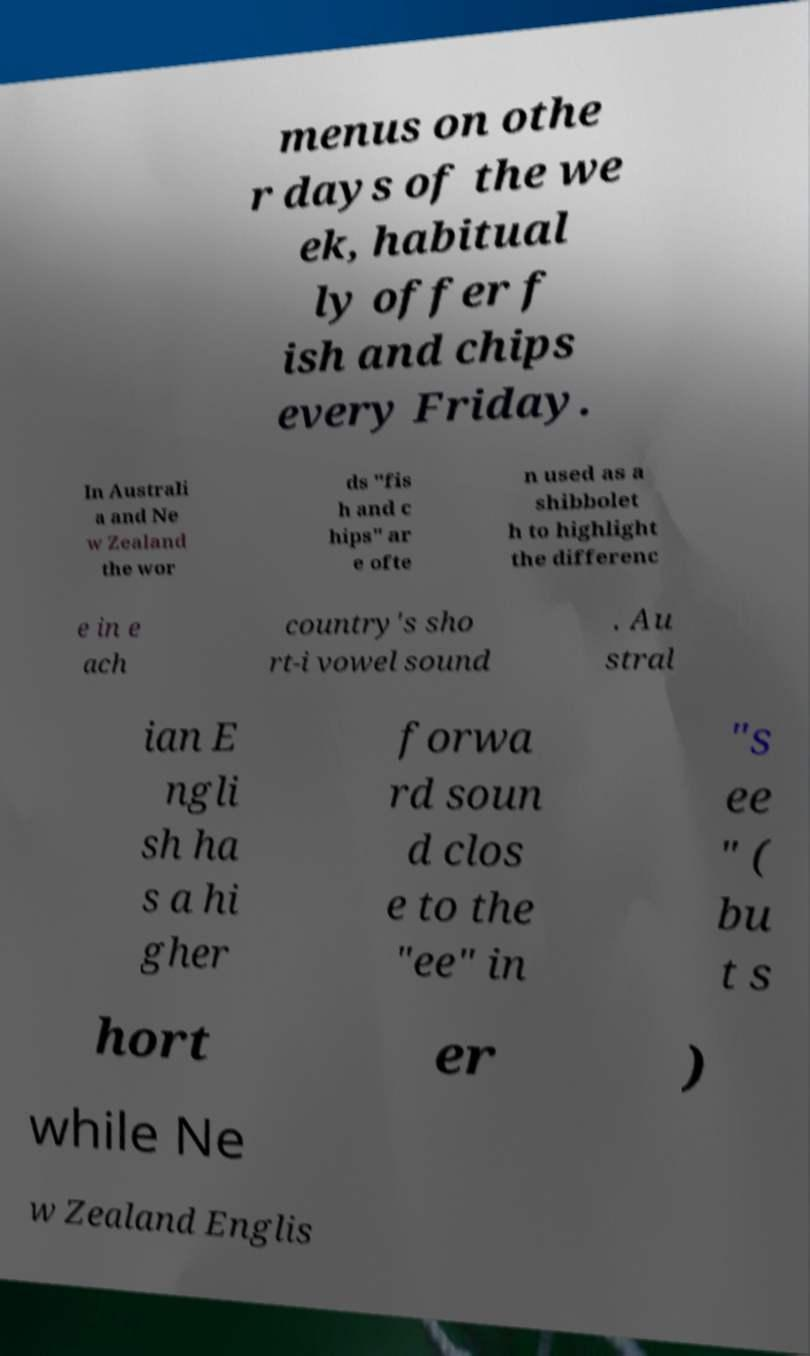There's text embedded in this image that I need extracted. Can you transcribe it verbatim? menus on othe r days of the we ek, habitual ly offer f ish and chips every Friday. In Australi a and Ne w Zealand the wor ds "fis h and c hips" ar e ofte n used as a shibbolet h to highlight the differenc e in e ach country's sho rt-i vowel sound . Au stral ian E ngli sh ha s a hi gher forwa rd soun d clos e to the "ee" in "s ee " ( bu t s hort er ) while Ne w Zealand Englis 